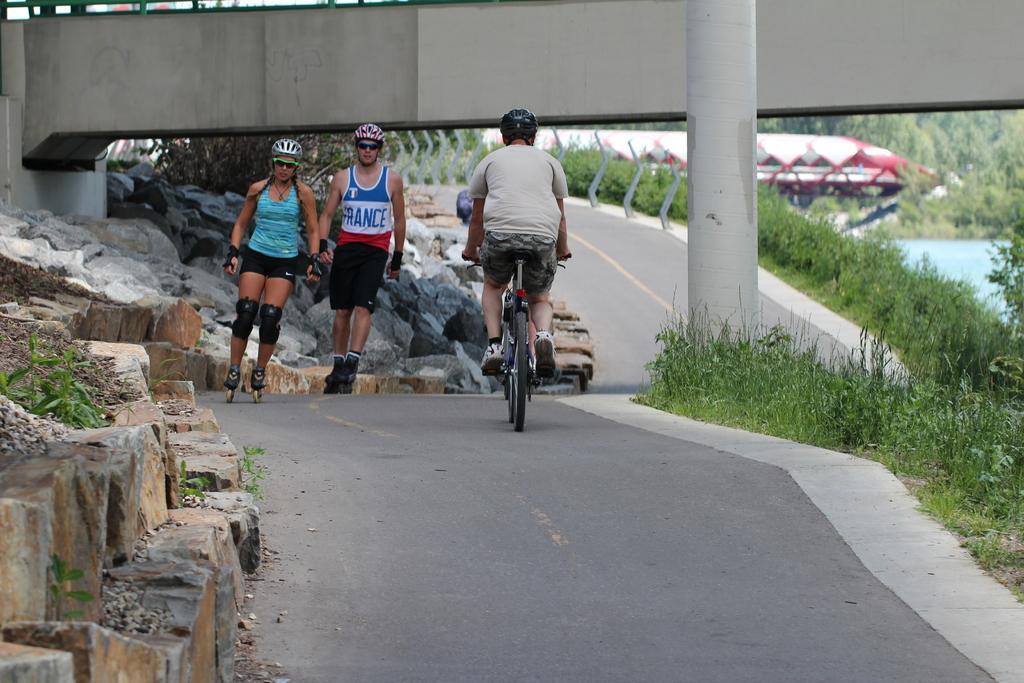Please provide a concise description of this image. As we can see in the image, there are trees, grass, bridge and two people on road and a man riding bicycle. 